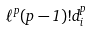<formula> <loc_0><loc_0><loc_500><loc_500>\ell ^ { p } ( p - 1 ) ! d _ { i } ^ { p }</formula> 